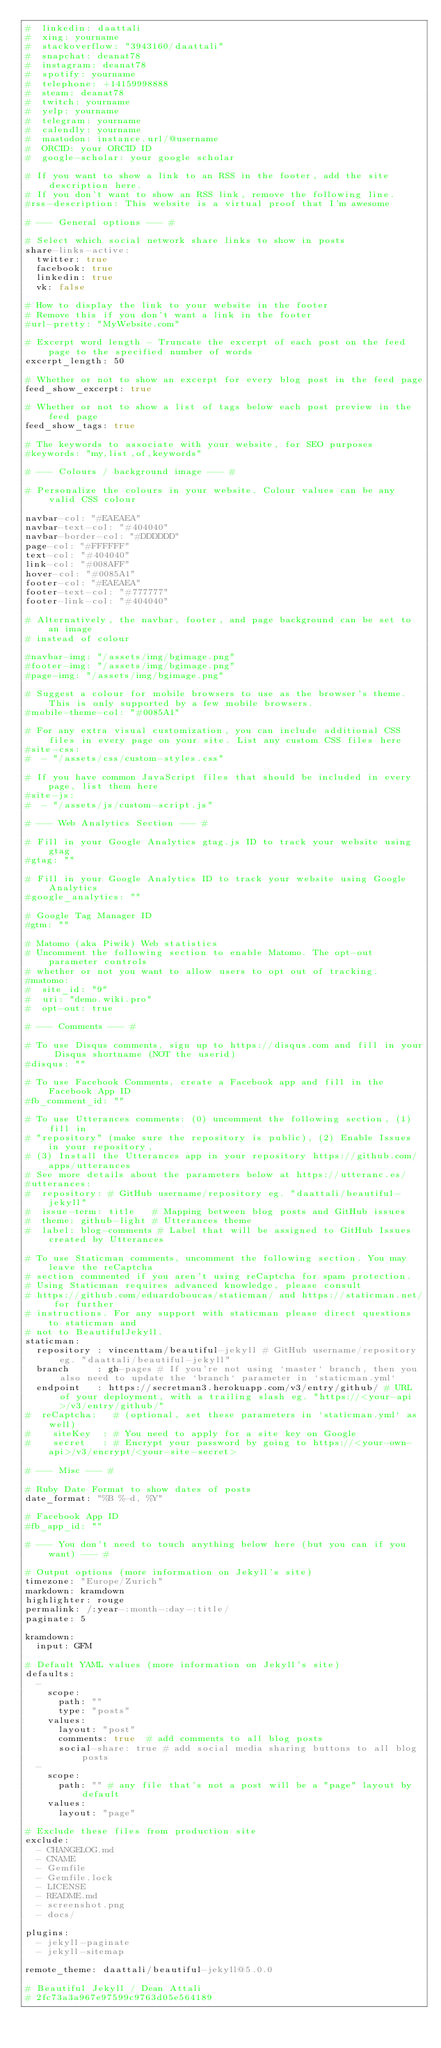Convert code to text. <code><loc_0><loc_0><loc_500><loc_500><_YAML_>#  linkedin: daattali
#  xing: yourname
#  stackoverflow: "3943160/daattali"
#  snapchat: deanat78
#  instagram: deanat78
#  spotify: yourname
#  telephone: +14159998888
#  steam: deanat78
#  twitch: yourname
#  yelp: yourname
#  telegram: yourname
#  calendly: yourname
#  mastodon: instance.url/@username
#  ORCID: your ORCID ID
#  google-scholar: your google scholar

# If you want to show a link to an RSS in the footer, add the site description here.
# If you don't want to show an RSS link, remove the following line.
#rss-description: This website is a virtual proof that I'm awesome

# --- General options --- #

# Select which social network share links to show in posts
share-links-active:
  twitter: true
  facebook: true
  linkedin: true
  vk: false

# How to display the link to your website in the footer
# Remove this if you don't want a link in the footer
#url-pretty: "MyWebsite.com"

# Excerpt word length - Truncate the excerpt of each post on the feed page to the specified number of words
excerpt_length: 50

# Whether or not to show an excerpt for every blog post in the feed page
feed_show_excerpt: true

# Whether or not to show a list of tags below each post preview in the feed page
feed_show_tags: true

# The keywords to associate with your website, for SEO purposes
#keywords: "my,list,of,keywords"

# --- Colours / background image --- #

# Personalize the colours in your website. Colour values can be any valid CSS colour

navbar-col: "#EAEAEA"
navbar-text-col: "#404040"
navbar-border-col: "#DDDDDD"
page-col: "#FFFFFF"
text-col: "#404040"
link-col: "#008AFF"
hover-col: "#0085A1"
footer-col: "#EAEAEA"
footer-text-col: "#777777"
footer-link-col: "#404040"

# Alternatively, the navbar, footer, and page background can be set to an image
# instead of colour

#navbar-img: "/assets/img/bgimage.png"
#footer-img: "/assets/img/bgimage.png"
#page-img: "/assets/img/bgimage.png"

# Suggest a colour for mobile browsers to use as the browser's theme. This is only supported by a few mobile browsers.
#mobile-theme-col: "#0085A1"

# For any extra visual customization, you can include additional CSS files in every page on your site. List any custom CSS files here
#site-css:
#  - "/assets/css/custom-styles.css"

# If you have common JavaScript files that should be included in every page, list them here
#site-js:
#  - "/assets/js/custom-script.js"

# --- Web Analytics Section --- #

# Fill in your Google Analytics gtag.js ID to track your website using gtag
#gtag: ""

# Fill in your Google Analytics ID to track your website using Google Analytics
#google_analytics: ""

# Google Tag Manager ID
#gtm: ""

# Matomo (aka Piwik) Web statistics
# Uncomment the following section to enable Matomo. The opt-out parameter controls
# whether or not you want to allow users to opt out of tracking.
#matomo:
#  site_id: "9"
#  uri: "demo.wiki.pro"
#  opt-out: true

# --- Comments --- #

# To use Disqus comments, sign up to https://disqus.com and fill in your Disqus shortname (NOT the userid)
#disqus: ""

# To use Facebook Comments, create a Facebook app and fill in the Facebook App ID
#fb_comment_id: ""

# To use Utterances comments: (0) uncomment the following section, (1) fill in
# "repository" (make sure the repository is public), (2) Enable Issues in your repository,
# (3) Install the Utterances app in your repository https://github.com/apps/utterances
# See more details about the parameters below at https://utteranc.es/
#utterances:
#  repository: # GitHub username/repository eg. "daattali/beautiful-jekyll"
#  issue-term: title   # Mapping between blog posts and GitHub issues
#  theme: github-light # Utterances theme
#  label: blog-comments # Label that will be assigned to GitHub Issues created by Utterances

# To use Staticman comments, uncomment the following section. You may leave the reCaptcha
# section commented if you aren't using reCaptcha for spam protection. 
# Using Staticman requires advanced knowledge, please consult 
# https://github.com/eduardoboucas/staticman/ and https://staticman.net/ for further 
# instructions. For any support with staticman please direct questions to staticman and 
# not to BeautifulJekyll.
staticman:
  repository : vincenttam/beautiful-jekyll # GitHub username/repository eg. "daattali/beautiful-jekyll"
  branch     : gh-pages # If you're not using `master` branch, then you also need to update the `branch` parameter in `staticman.yml`
  endpoint   : https://secretman3.herokuapp.com/v3/entry/github/ # URL of your deployment, with a trailing slash eg. "https://<your-api>/v3/entry/github/"
#  reCaptcha:   # (optional, set these parameters in `staticman.yml` as well) 
#    siteKey  : # You need to apply for a site key on Google
#    secret   : # Encrypt your password by going to https://<your-own-api>/v3/encrypt/<your-site-secret>

# --- Misc --- #

# Ruby Date Format to show dates of posts
date_format: "%B %-d, %Y"

# Facebook App ID
#fb_app_id: ""

# --- You don't need to touch anything below here (but you can if you want) --- #

# Output options (more information on Jekyll's site)
timezone: "Europe/Zurich"
markdown: kramdown
highlighter: rouge
permalink: /:year-:month-:day-:title/
paginate: 5

kramdown:
  input: GFM

# Default YAML values (more information on Jekyll's site)
defaults:
  -
    scope:
      path: ""
      type: "posts"
    values:
      layout: "post"
      comments: true  # add comments to all blog posts
      social-share: true # add social media sharing buttons to all blog posts
  -
    scope:
      path: "" # any file that's not a post will be a "page" layout by default
    values:
      layout: "page"

# Exclude these files from production site
exclude:
  - CHANGELOG.md
  - CNAME
  - Gemfile
  - Gemfile.lock
  - LICENSE
  - README.md
  - screenshot.png
  - docs/

plugins:
  - jekyll-paginate
  - jekyll-sitemap

remote_theme: daattali/beautiful-jekyll@5.0.0

# Beautiful Jekyll / Dean Attali
# 2fc73a3a967e97599c9763d05e564189
</code> 